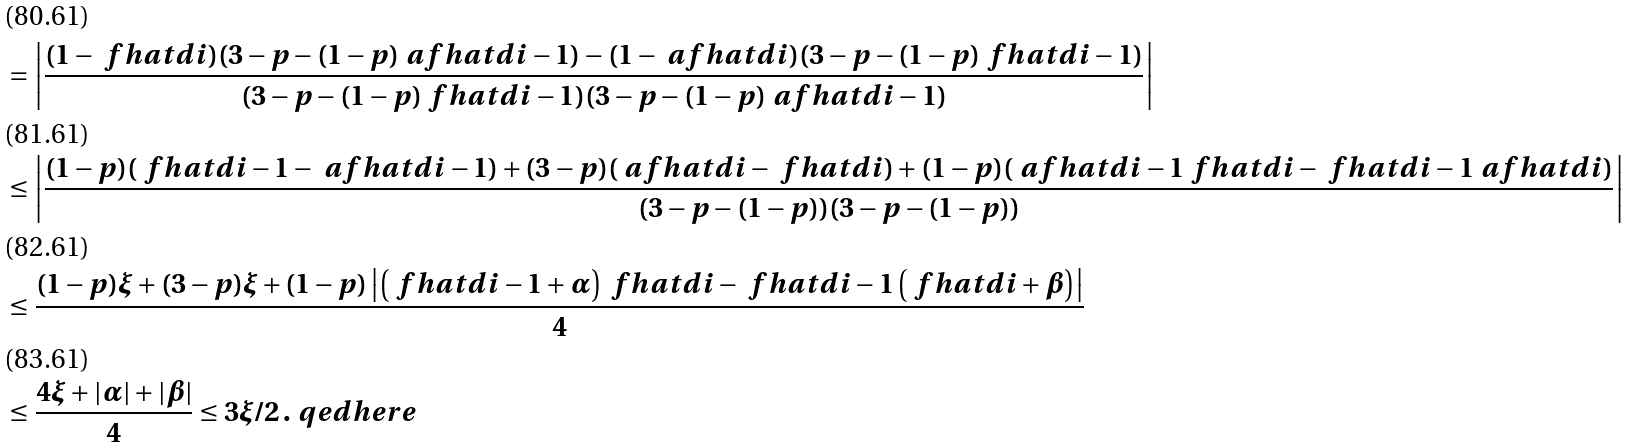<formula> <loc_0><loc_0><loc_500><loc_500>& = \left | \frac { ( 1 - \ f h a t { d } { i } ) ( 3 - p - ( 1 - p ) \ a f h a t { d } { i - 1 } ) - ( 1 - \ a f h a t { d } { i } ) ( 3 - p - ( 1 - p ) \ f h a t { d } { i - 1 } ) } { ( 3 - p - ( 1 - p ) \ f h a t { d } { i - 1 } ) ( 3 - p - ( 1 - p ) \ a f h a t { d } { i - 1 } ) } \right | \\ & \leq \left | \frac { ( 1 - p ) ( \ f h a t { d } { i - 1 } - \ a f h a t { d } { i - 1 } ) + ( 3 - p ) ( \ a f h a t { d } { i } - \ f h a t { d } { i } ) + ( 1 - p ) ( \ a f h a t { d } { i - 1 } \ f h a t { d } { i } - \ f h a t { d } { i - 1 } \ a f h a t { d } { i } ) } { ( 3 - p - ( 1 - p ) ) ( 3 - p - ( 1 - p ) ) } \right | \\ & \leq \frac { ( 1 - p ) \xi + ( 3 - p ) \xi + ( 1 - p ) \left | \left ( \ f h a t { d } { i - 1 } + \alpha \right ) \ f h a t { d } { i } - \ f h a t { d } { i - 1 } \left ( \ f h a t { d } { i } + \beta \right ) \right | } { 4 } \\ & \leq \frac { 4 \xi + | \alpha | + | \beta | } { 4 } \leq 3 \xi / 2 \, . \ q e d h e r e</formula> 